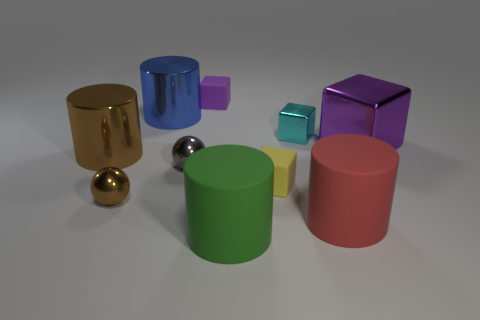Subtract all blue metal cylinders. How many cylinders are left? 3 Subtract all red cylinders. How many cylinders are left? 3 Subtract 0 cyan cylinders. How many objects are left? 10 Subtract all cubes. How many objects are left? 6 Subtract 2 cylinders. How many cylinders are left? 2 Subtract all yellow blocks. Subtract all brown cylinders. How many blocks are left? 3 Subtract all yellow cylinders. How many red balls are left? 0 Subtract all purple rubber blocks. Subtract all tiny purple cubes. How many objects are left? 8 Add 5 green objects. How many green objects are left? 6 Add 6 big blue objects. How many big blue objects exist? 7 